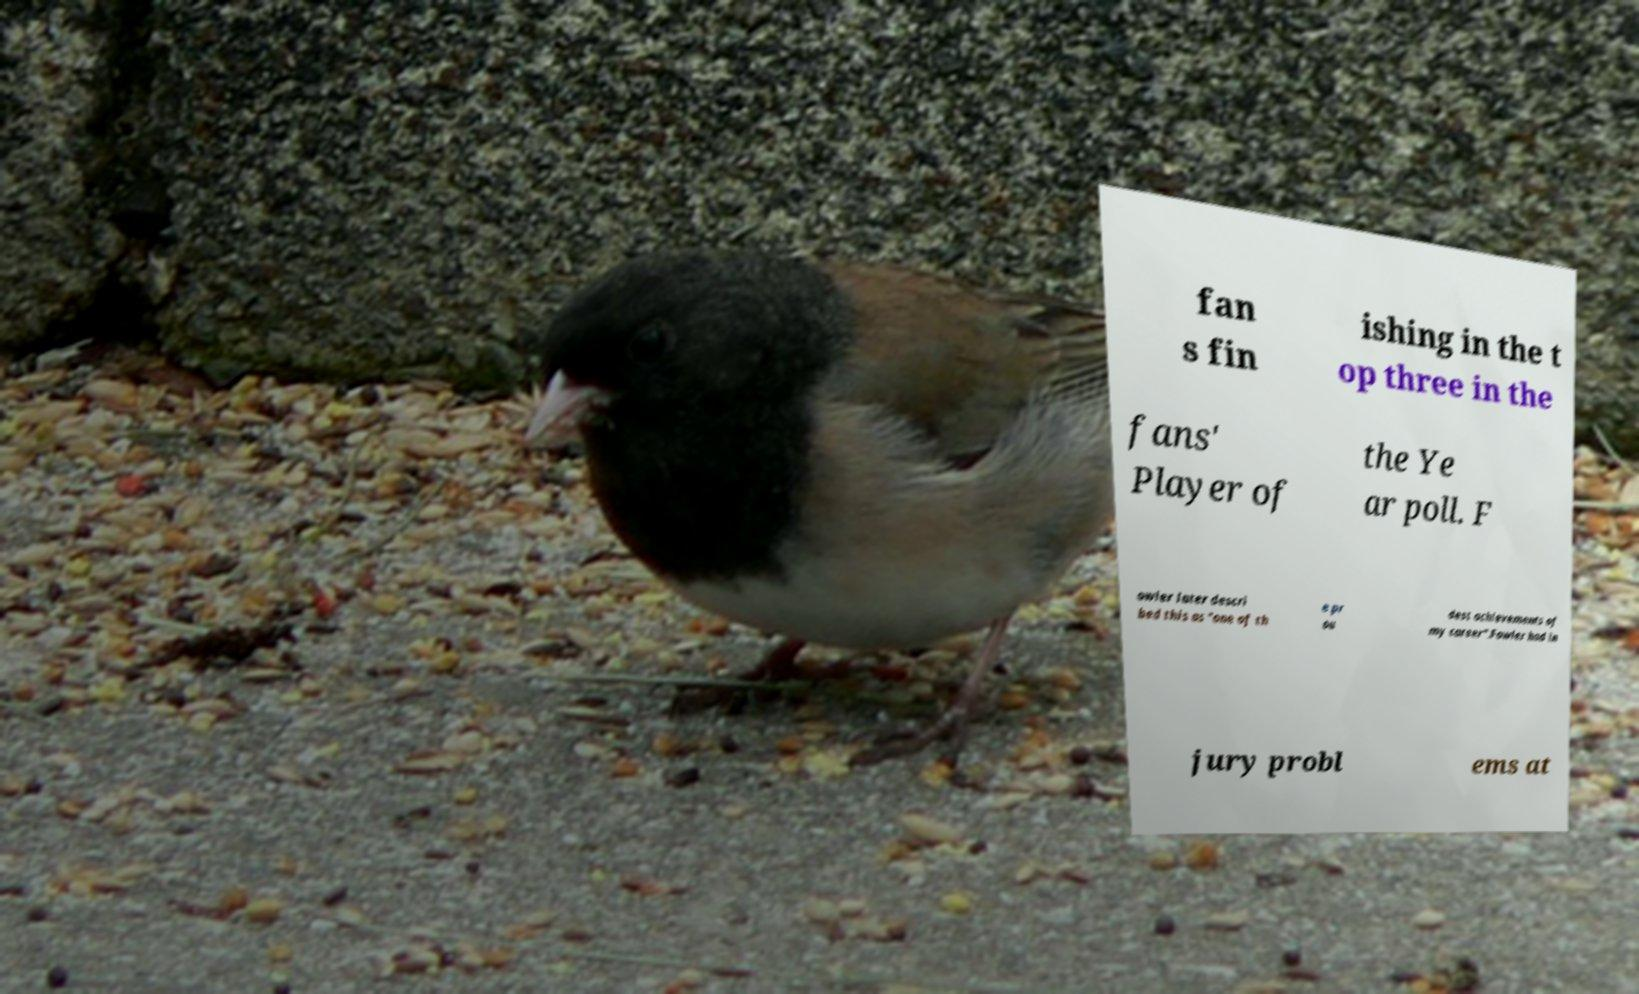Please identify and transcribe the text found in this image. fan s fin ishing in the t op three in the fans' Player of the Ye ar poll. F owler later descri bed this as "one of th e pr ou dest achievements of my career".Fowler had in jury probl ems at 